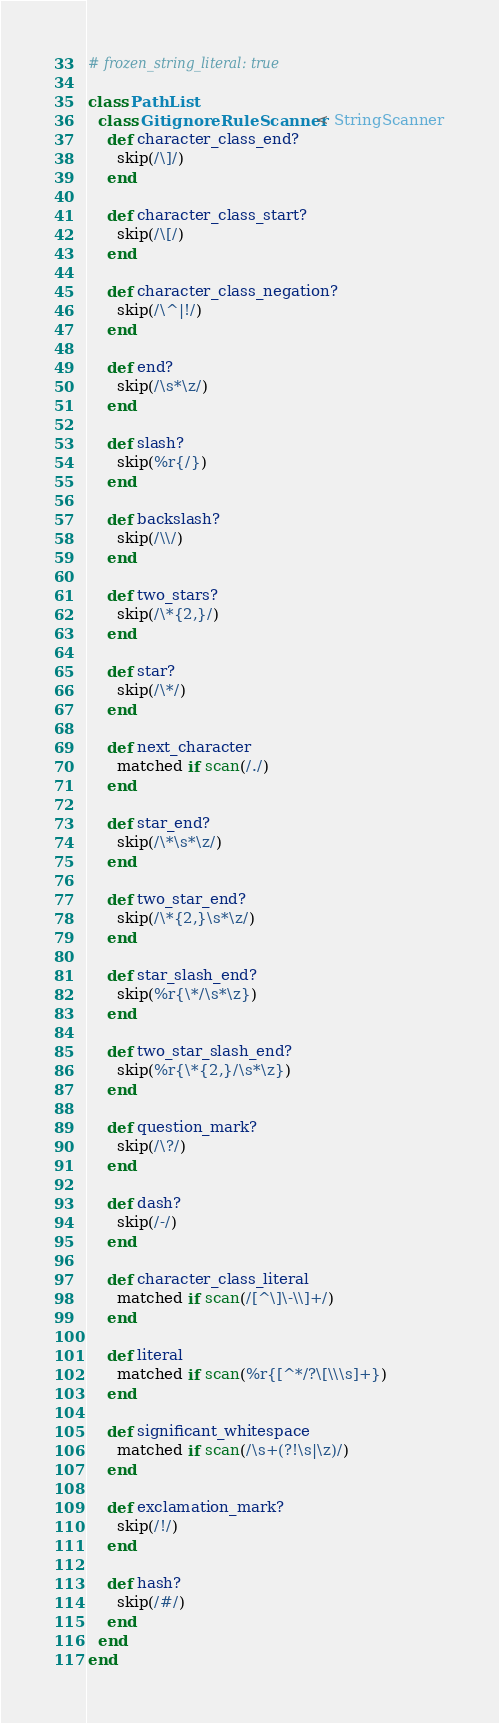Convert code to text. <code><loc_0><loc_0><loc_500><loc_500><_Ruby_># frozen_string_literal: true

class PathList
  class GitignoreRuleScanner < StringScanner
    def character_class_end?
      skip(/\]/)
    end

    def character_class_start?
      skip(/\[/)
    end

    def character_class_negation?
      skip(/\^|!/)
    end

    def end?
      skip(/\s*\z/)
    end

    def slash?
      skip(%r{/})
    end

    def backslash?
      skip(/\\/)
    end

    def two_stars?
      skip(/\*{2,}/)
    end

    def star?
      skip(/\*/)
    end

    def next_character
      matched if scan(/./)
    end

    def star_end?
      skip(/\*\s*\z/)
    end

    def two_star_end?
      skip(/\*{2,}\s*\z/)
    end

    def star_slash_end?
      skip(%r{\*/\s*\z})
    end

    def two_star_slash_end?
      skip(%r{\*{2,}/\s*\z})
    end

    def question_mark?
      skip(/\?/)
    end

    def dash?
      skip(/-/)
    end

    def character_class_literal
      matched if scan(/[^\]\-\\]+/)
    end

    def literal
      matched if scan(%r{[^*/?\[\\\s]+})
    end

    def significant_whitespace
      matched if scan(/\s+(?!\s|\z)/)
    end

    def exclamation_mark?
      skip(/!/)
    end

    def hash?
      skip(/#/)
    end
  end
end
</code> 